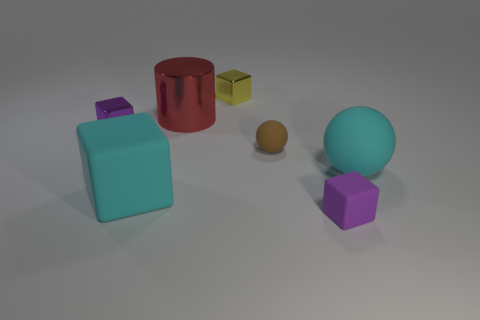Subtract all big cyan cubes. How many cubes are left? 3 Add 3 yellow things. How many objects exist? 10 Subtract all spheres. How many objects are left? 5 Subtract all purple cubes. How many cubes are left? 2 Subtract 1 spheres. How many spheres are left? 1 Subtract all cyan balls. Subtract all blue cylinders. How many balls are left? 1 Subtract all green cylinders. How many yellow balls are left? 0 Subtract all spheres. Subtract all large cyan objects. How many objects are left? 3 Add 3 cyan balls. How many cyan balls are left? 4 Add 6 big balls. How many big balls exist? 7 